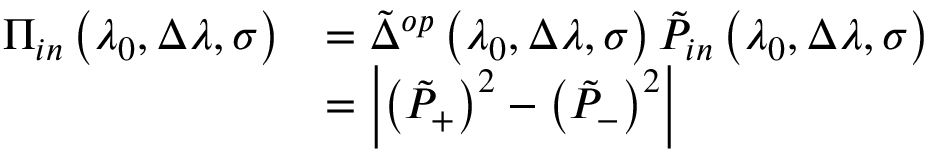Convert formula to latex. <formula><loc_0><loc_0><loc_500><loc_500>\begin{array} { r l } { \Pi _ { i n } \left ( \lambda _ { 0 } , \Delta \lambda , \sigma \right ) } & { = \tilde { \Delta } ^ { o p } \left ( \lambda _ { 0 } , \Delta \lambda , \sigma \right ) \tilde { P } _ { i n } \left ( \lambda _ { 0 } , \Delta \lambda , \sigma \right ) } \\ & { = \left | \left ( \tilde { P } _ { + } \right ) ^ { 2 } - \left ( \tilde { P } _ { - } \right ) ^ { 2 } \right | } \end{array}</formula> 